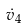Convert formula to latex. <formula><loc_0><loc_0><loc_500><loc_500>\dot { v } _ { 4 }</formula> 